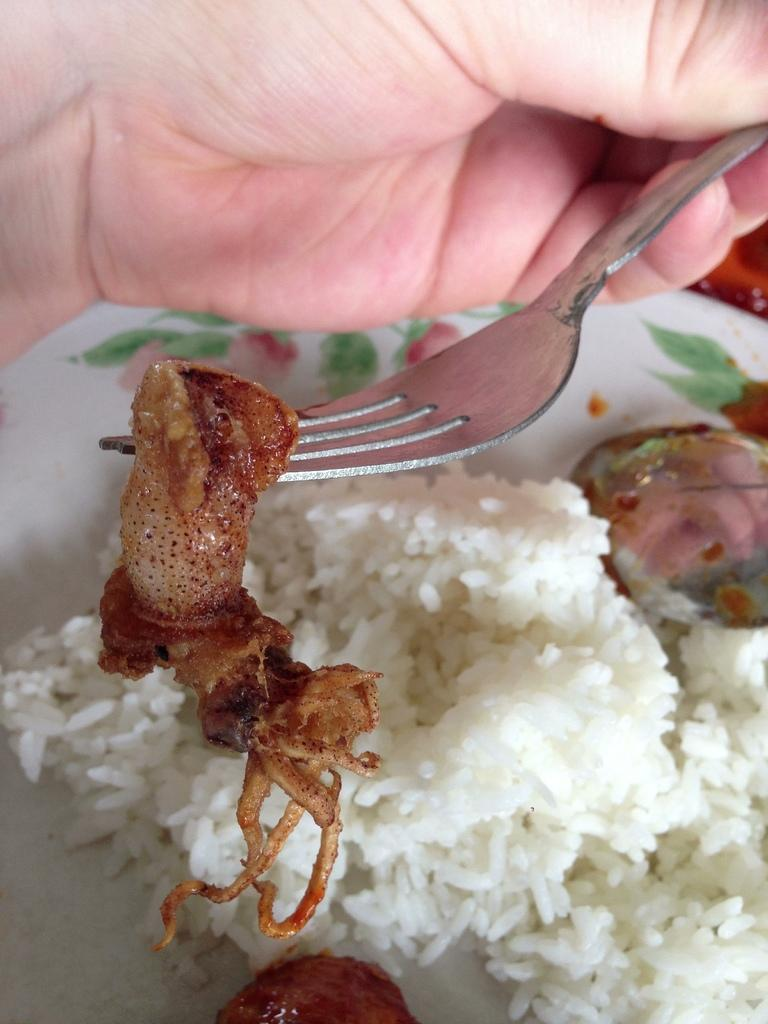What object is being held by a person's hand in the image? A person's hand is holding a fork in the image. What type of dish is present on the plate in the image? There is a white color plate in the image. What color is the food on the plate? There is brown color food in the image. What type of food is visible on the plate? There is white color rice in the image. What type of motion is the fork making in the image? The fork is not making any motion in the image; it is being held by a person's hand. 